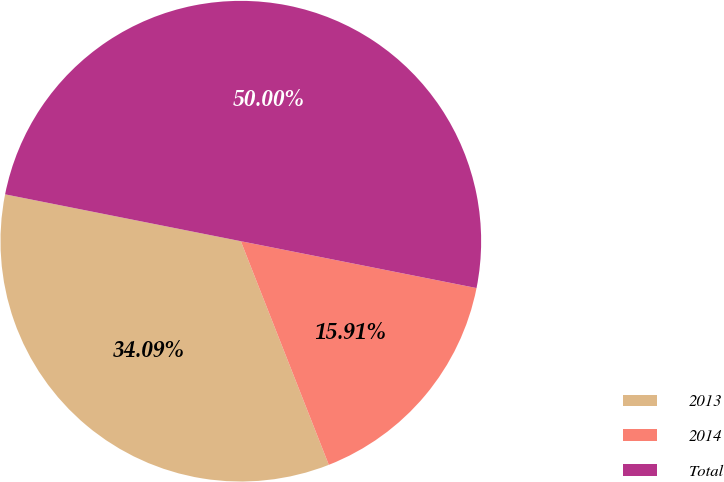Convert chart to OTSL. <chart><loc_0><loc_0><loc_500><loc_500><pie_chart><fcel>2013<fcel>2014<fcel>Total<nl><fcel>34.09%<fcel>15.91%<fcel>50.0%<nl></chart> 